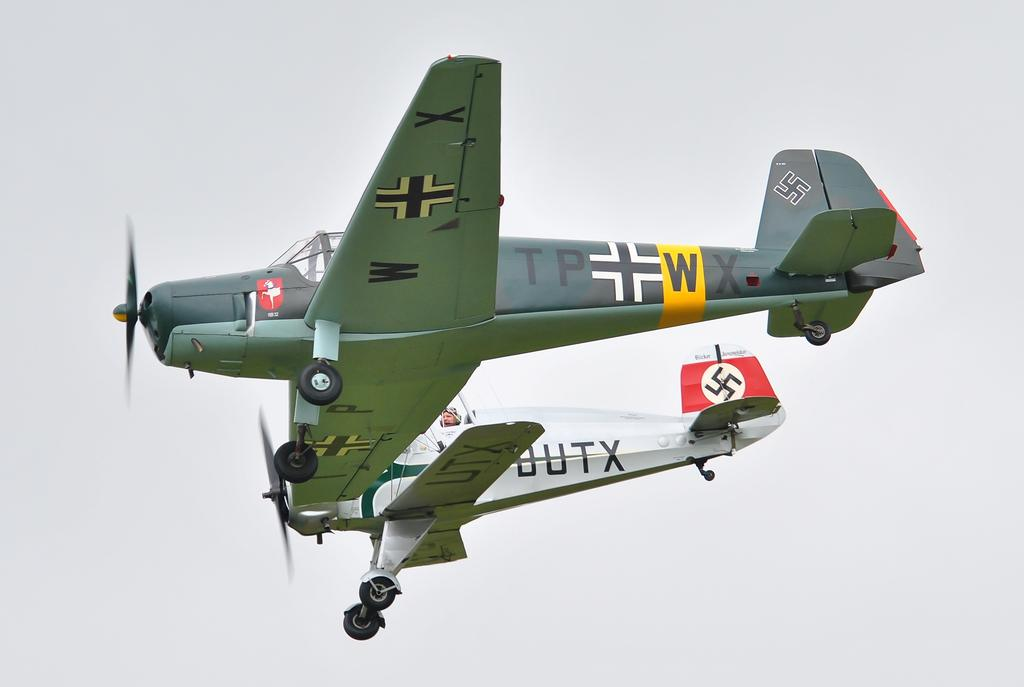<image>
Offer a succinct explanation of the picture presented. Two old military planes have propellers and swastikas, one has TPWX painted on the fuselage. 